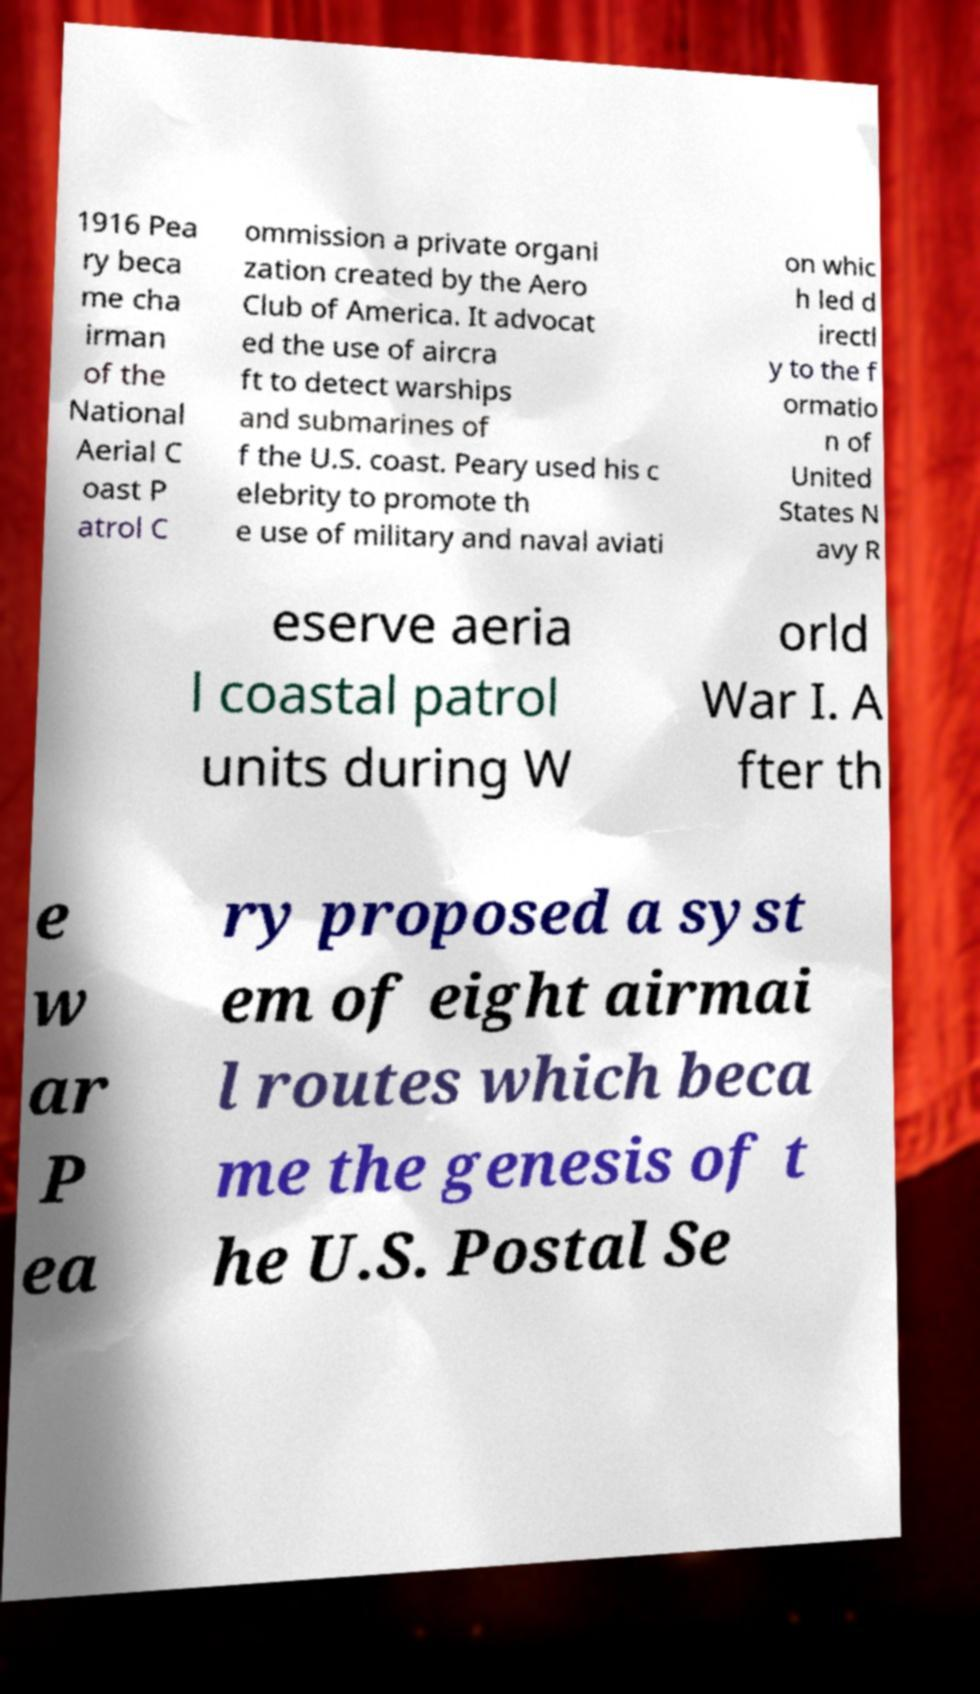I need the written content from this picture converted into text. Can you do that? 1916 Pea ry beca me cha irman of the National Aerial C oast P atrol C ommission a private organi zation created by the Aero Club of America. It advocat ed the use of aircra ft to detect warships and submarines of f the U.S. coast. Peary used his c elebrity to promote th e use of military and naval aviati on whic h led d irectl y to the f ormatio n of United States N avy R eserve aeria l coastal patrol units during W orld War I. A fter th e w ar P ea ry proposed a syst em of eight airmai l routes which beca me the genesis of t he U.S. Postal Se 